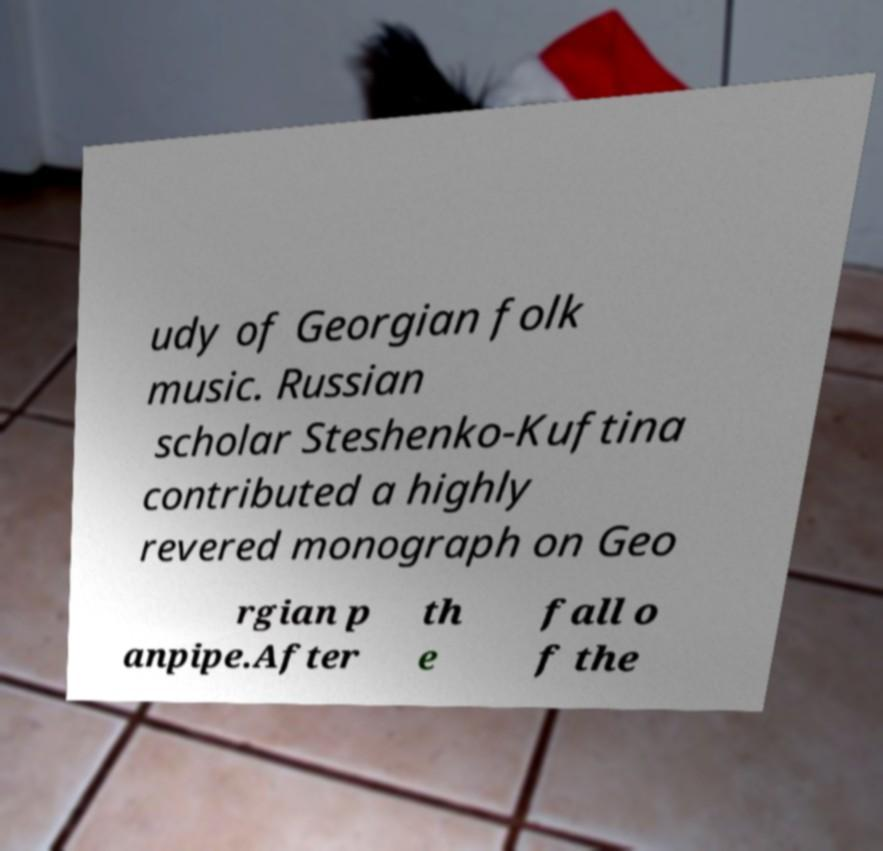Can you accurately transcribe the text from the provided image for me? udy of Georgian folk music. Russian scholar Steshenko-Kuftina contributed a highly revered monograph on Geo rgian p anpipe.After th e fall o f the 